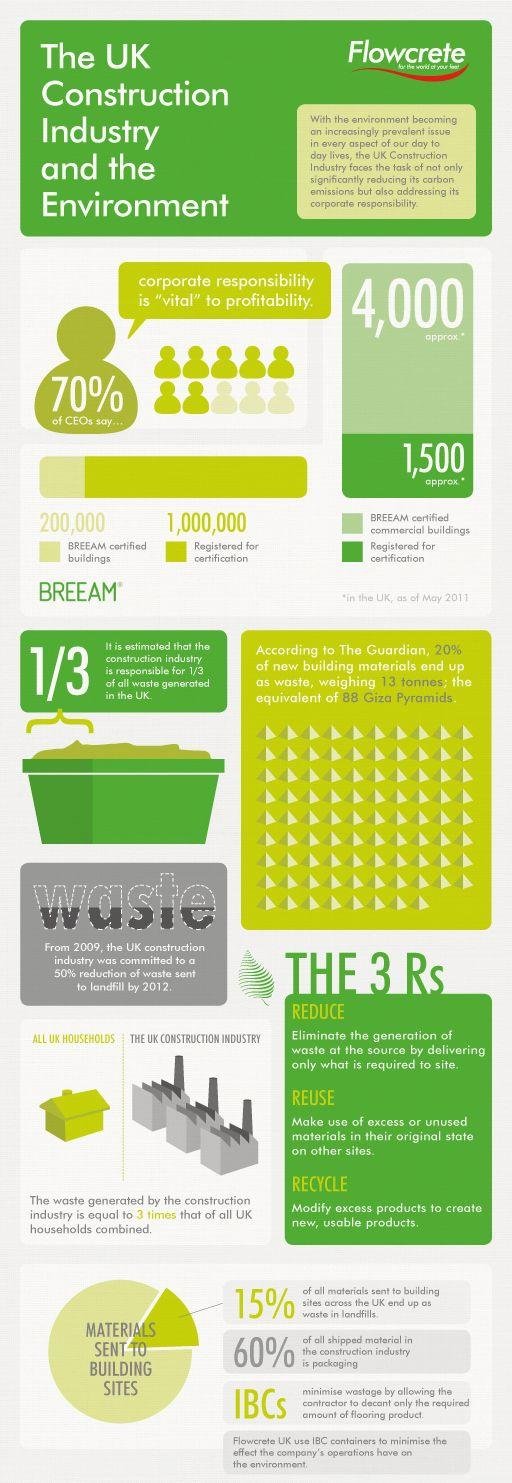Outline some significant characteristics in this image. The total number of BREEAM-certified buildings in the UK is approximately 200,000. The construction industry in the UK produces three times more waste than households, according to recent statistics. Seventy percent of CEOs believe that corporate responsibility is crucial to profitability, according to a recent survey. BREEAM certification has been applied to approximately 1,500 commercial buildings. According to data, 15% of the raw materials used in construction sites are ending up in landfills. 